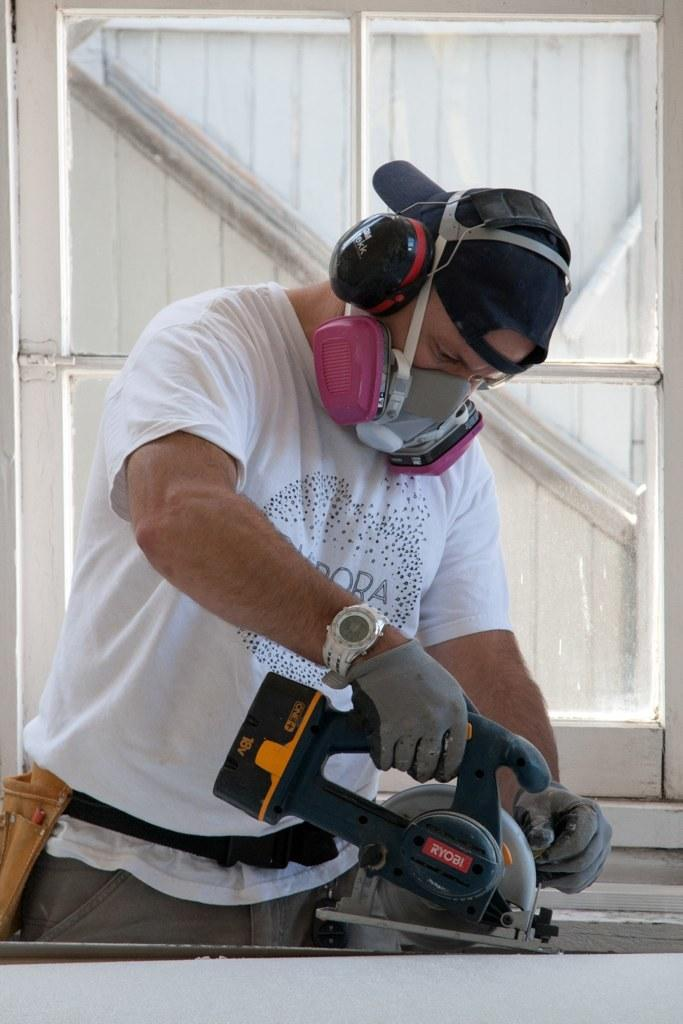What is the main subject of the image? The main subject of the image is a man. What is the man doing in the image? The man is standing in the image. What is the man holding in his hand? The man is holding a machine in his hand. What is the man wearing on his upper body? The man is wearing a white t-shirt. What is the man wearing on his head? The man is wearing a headphone. What is the man wearing to protect himself from the pandemic? The man is wearing a mask. What can be seen behind the man in the image? There is a white color window behind the man. What type of discussion is the man having with the foot in the image? There is no foot present in the image, and therefore no such discussion can be observed. 